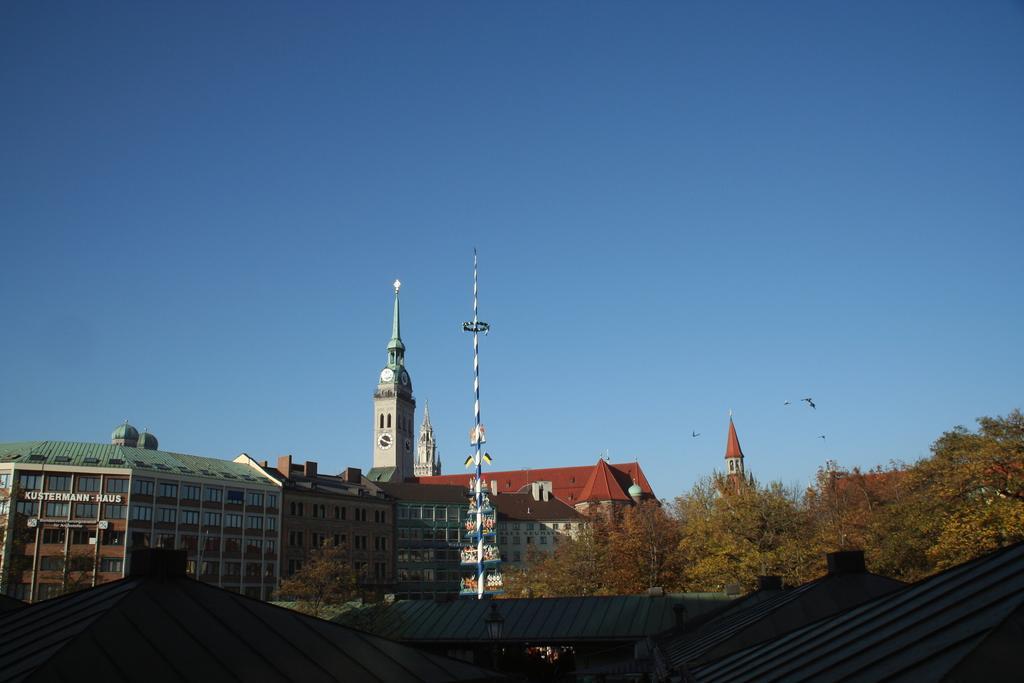Can you describe this image briefly? In this picture there is a brown color building with many glass window and a clock tower. In the front bottom side there are some sheds and brown color trees. 